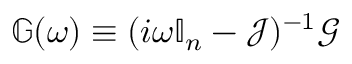Convert formula to latex. <formula><loc_0><loc_0><loc_500><loc_500>\mathbb { G } ( \omega ) \equiv ( i \omega \mathbb { I } _ { n } - \mathcal { J } ) ^ { - 1 } \mathcal { G }</formula> 